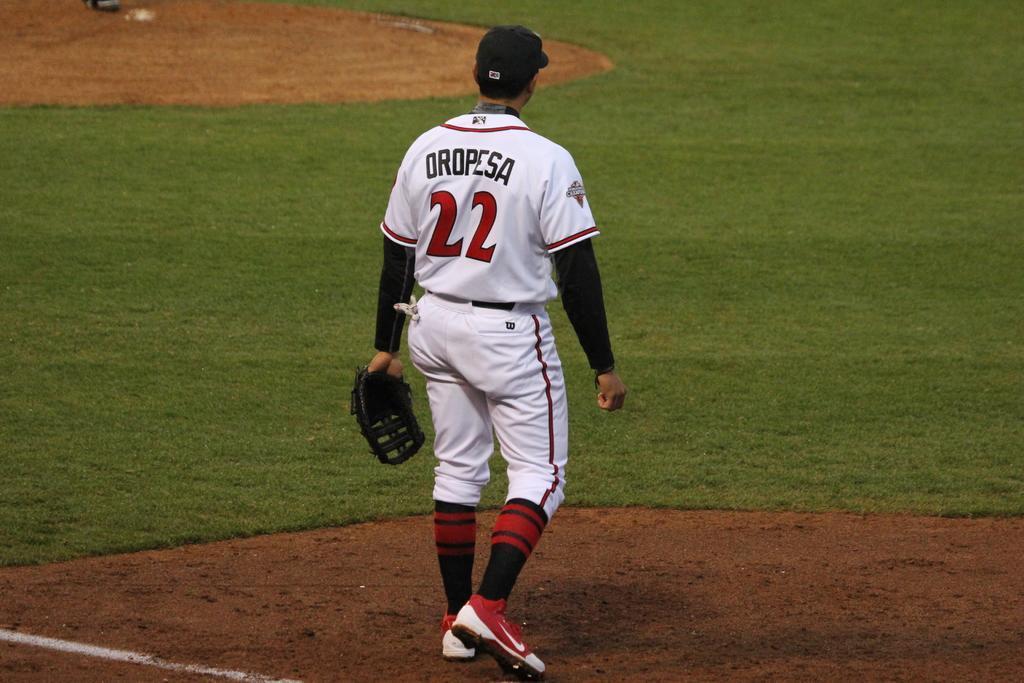<image>
Share a concise interpretation of the image provided. A ball player with the name Oropesa and the number 22 on the back of his shirt. 